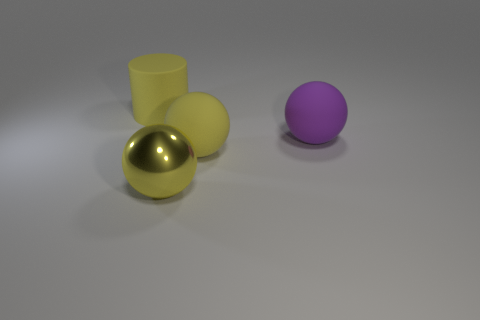Are there more big yellow things than large objects?
Offer a terse response. No. What number of things are yellow matte things that are to the left of the large yellow rubber ball or purple spheres?
Make the answer very short. 2. Does the large yellow cylinder have the same material as the big purple ball?
Give a very brief answer. Yes. The other rubber thing that is the same shape as the purple object is what size?
Make the answer very short. Large. There is a big yellow rubber thing that is behind the purple rubber sphere; is it the same shape as the big matte object in front of the big purple matte ball?
Provide a succinct answer. No. There is a purple thing; is it the same size as the yellow matte object in front of the cylinder?
Your answer should be very brief. Yes. How many other objects are there of the same material as the large purple object?
Your response must be concise. 2. There is a big object that is in front of the large matte sphere left of the purple sphere that is right of the big metal object; what is its color?
Make the answer very short. Yellow. What shape is the object that is both in front of the large purple ball and on the right side of the large metallic ball?
Your response must be concise. Sphere. What color is the rubber object behind the large purple rubber object behind the yellow matte ball?
Make the answer very short. Yellow. 